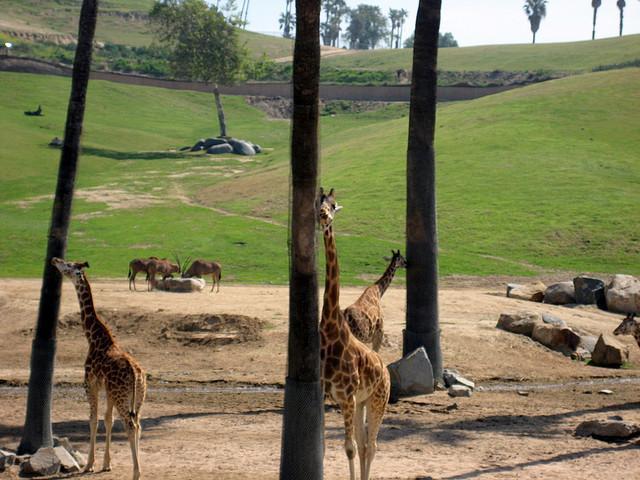How many giraffes are there?
Give a very brief answer. 3. 